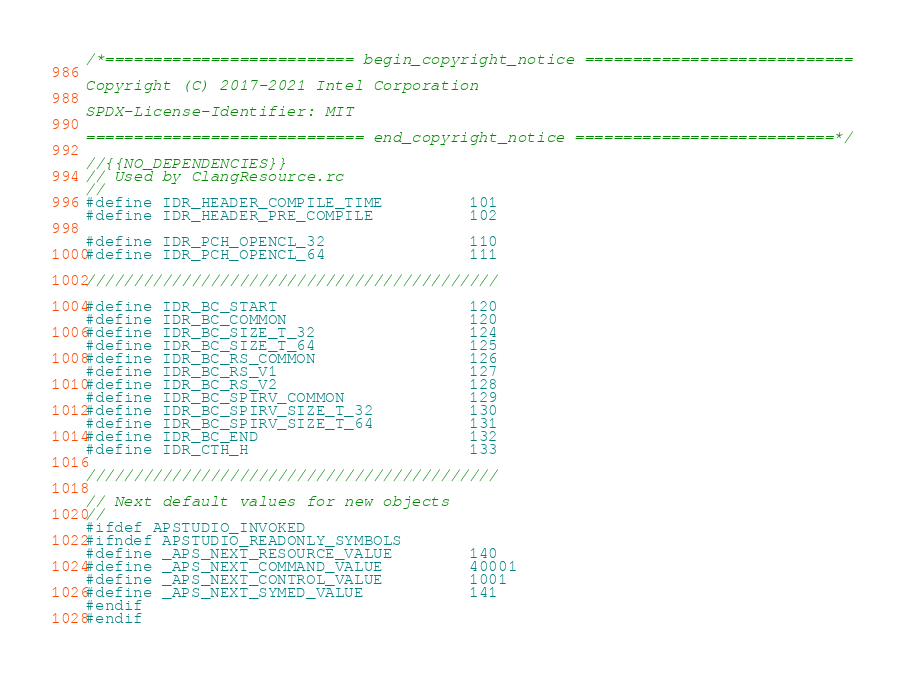Convert code to text. <code><loc_0><loc_0><loc_500><loc_500><_C_>/*========================== begin_copyright_notice ============================

Copyright (C) 2017-2021 Intel Corporation

SPDX-License-Identifier: MIT

============================= end_copyright_notice ===========================*/

//{{NO_DEPENDENCIES}}
// Used by ClangResource.rc
//
#define IDR_HEADER_COMPILE_TIME         101
#define IDR_HEADER_PRE_COMPILE          102

#define IDR_PCH_OPENCL_32               110
#define IDR_PCH_OPENCL_64               111

///////////////////////////////////////////

#define IDR_BC_START                    120
#define IDR_BC_COMMON                   120
#define IDR_BC_SIZE_T_32                124
#define IDR_BC_SIZE_T_64                125
#define IDR_BC_RS_COMMON                126
#define IDR_BC_RS_V1                    127
#define IDR_BC_RS_V2                    128
#define IDR_BC_SPIRV_COMMON             129
#define IDR_BC_SPIRV_SIZE_T_32          130
#define IDR_BC_SPIRV_SIZE_T_64          131
#define IDR_BC_END                      132
#define IDR_CTH_H                       133

///////////////////////////////////////////

// Next default values for new objects
//
#ifdef APSTUDIO_INVOKED
#ifndef APSTUDIO_READONLY_SYMBOLS
#define _APS_NEXT_RESOURCE_VALUE        140
#define _APS_NEXT_COMMAND_VALUE         40001
#define _APS_NEXT_CONTROL_VALUE         1001
#define _APS_NEXT_SYMED_VALUE           141
#endif
#endif
</code> 